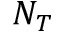Convert formula to latex. <formula><loc_0><loc_0><loc_500><loc_500>N _ { T }</formula> 